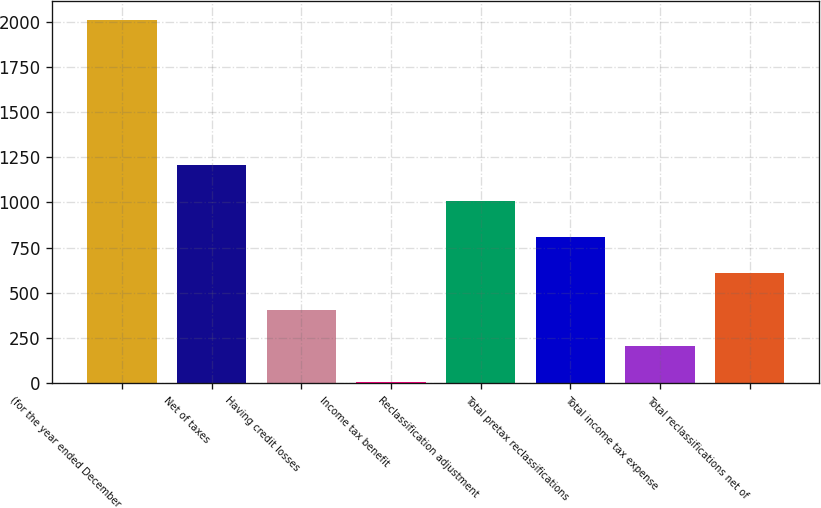<chart> <loc_0><loc_0><loc_500><loc_500><bar_chart><fcel>(for the year ended December<fcel>Net of taxes<fcel>Having credit losses<fcel>Income tax benefit<fcel>Reclassification adjustment<fcel>Total pretax reclassifications<fcel>Total income tax expense<fcel>Total reclassifications net of<nl><fcel>2011<fcel>1209<fcel>407<fcel>6<fcel>1008.5<fcel>808<fcel>206.5<fcel>607.5<nl></chart> 